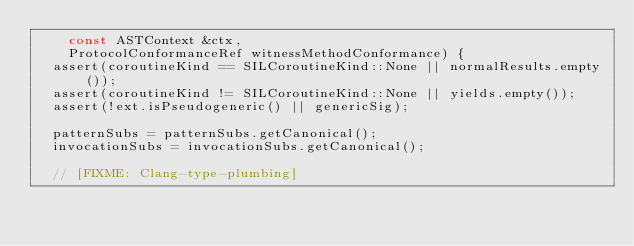<code> <loc_0><loc_0><loc_500><loc_500><_C++_>    const ASTContext &ctx,
    ProtocolConformanceRef witnessMethodConformance) {
  assert(coroutineKind == SILCoroutineKind::None || normalResults.empty());
  assert(coroutineKind != SILCoroutineKind::None || yields.empty());
  assert(!ext.isPseudogeneric() || genericSig);
  
  patternSubs = patternSubs.getCanonical();
  invocationSubs = invocationSubs.getCanonical();

  // [FIXME: Clang-type-plumbing]</code> 